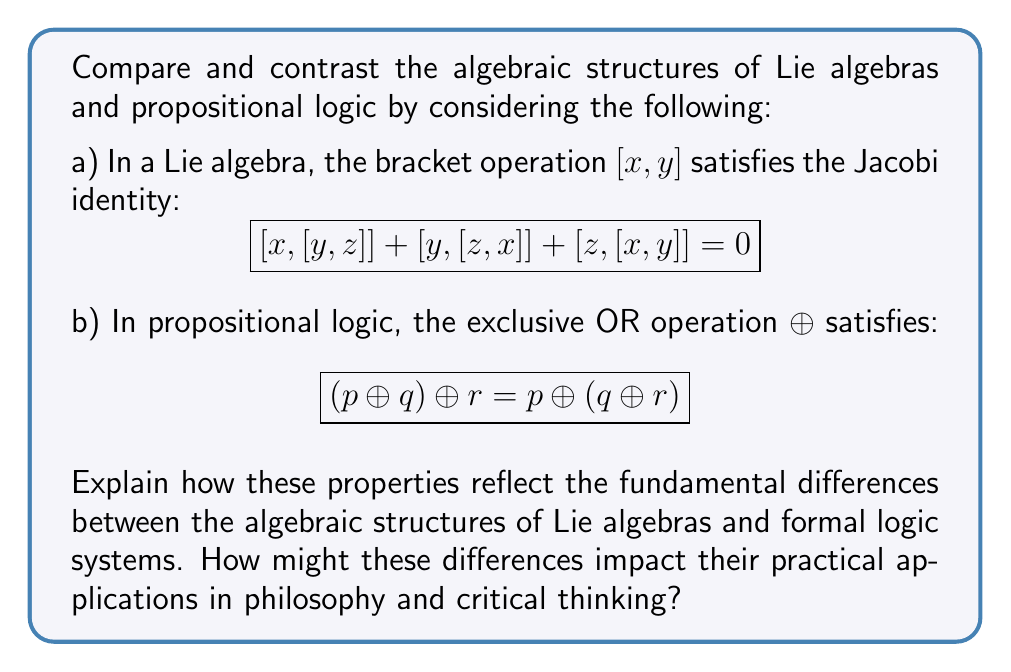Solve this math problem. To compare and contrast the algebraic structures of Lie algebras and propositional logic, we need to analyze the given properties and their implications:

1. Lie Algebra Structure:
   The Jacobi identity for Lie algebras, $[x,[y,z]] + [y,[z,x]] + [z,[x,y]] = 0$, is a fundamental property that reflects the non-associativity of the bracket operation. This identity ensures that the bracket operation behaves consistently under cyclic permutations of its arguments.

   Key points:
   - Non-associative operation
   - Antisymmetric: $[x,y] = -[y,x]$
   - Bilinear: $[ax+by,z] = a[x,z] + b[y,z]$

2. Propositional Logic Structure:
   The property $(p \oplus q) \oplus r = p \oplus (q \oplus r)$ for the exclusive OR operation in propositional logic demonstrates associativity. This means that the order of operations doesn't matter when applying the XOR operation to multiple propositions.

   Key points:
   - Associative operation
   - Commutative: $p \oplus q = q \oplus p$
   - Distributive over conjunction: $p \wedge (q \oplus r) = (p \wedge q) \oplus (p \wedge r)$

Fundamental differences:
1. Associativity: Lie algebras are non-associative, while propositional logic operations are associative. This means that in Lie algebras, the order of operations matters, leading to more complex relationships between elements.

2. Commutativity: The bracket operation in Lie algebras is antisymmetric, while logical operations like XOR are commutative. This reflects the directional nature of relationships in Lie algebras compared to the symmetric nature of logical operations.

3. Linearity: Lie algebras have a bilinear operation, which allows for scaling and addition of elements. Propositional logic deals with truth values and doesn't have a concept of scaling or addition in the same sense.

Practical applications in philosophy and critical thinking:

1. Lie algebras: The non-associative and antisymmetric nature of Lie algebras can be useful in modeling complex systems with hierarchical or directional relationships. In philosophy, this could be applied to analyzing power structures, causal relationships, or the evolution of ideas over time.

2. Propositional logic: The associative and commutative properties of logical operations make them well-suited for formal reasoning, argument analysis, and truth evaluation. These are directly applicable to philosophical debates and critical thinking exercises.

The choice between these structures depends on the nature of the problem being analyzed:

- For systems with complex, directional relationships: Lie algebras
- For formal reasoning and truth evaluation: Propositional logic

Understanding these differences can help a philosophy student appreciate the diverse mathematical tools available for modeling and analyzing different types of philosophical problems and arguments.
Answer: The fundamental differences between Lie algebras and propositional logic lie in their algebraic properties:

1. Associativity: Lie algebras are non-associative, while propositional logic operations are associative.
2. Commutativity: Lie algebra bracket operations are antisymmetric, while logical operations like XOR are commutative.
3. Linearity: Lie algebras have bilinear operations, while propositional logic deals with truth values without scaling or addition.

These differences impact their practical applications in philosophy and critical thinking:

- Lie algebras are suitable for modeling complex systems with hierarchical or directional relationships.
- Propositional logic is well-suited for formal reasoning, argument analysis, and truth evaluation.

The choice between these structures depends on whether the philosophical problem involves complex, directional relationships (Lie algebras) or formal reasoning and truth evaluation (propositional logic). 